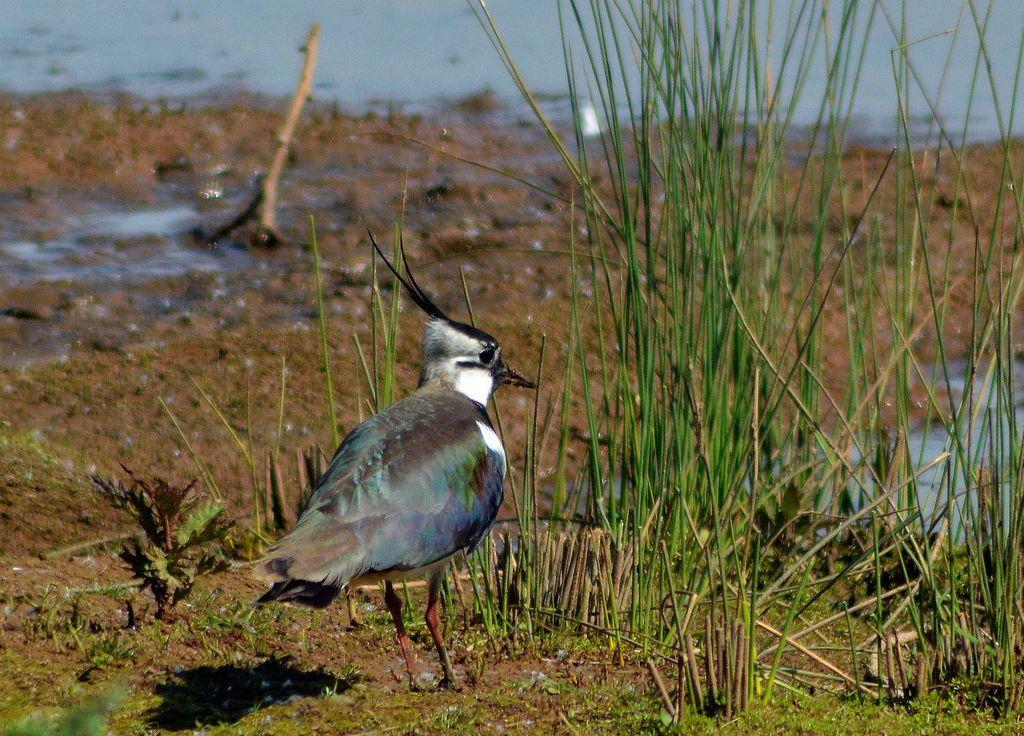In one or two sentences, can you explain what this image depicts? This picture consists of bird and grass and the lake 